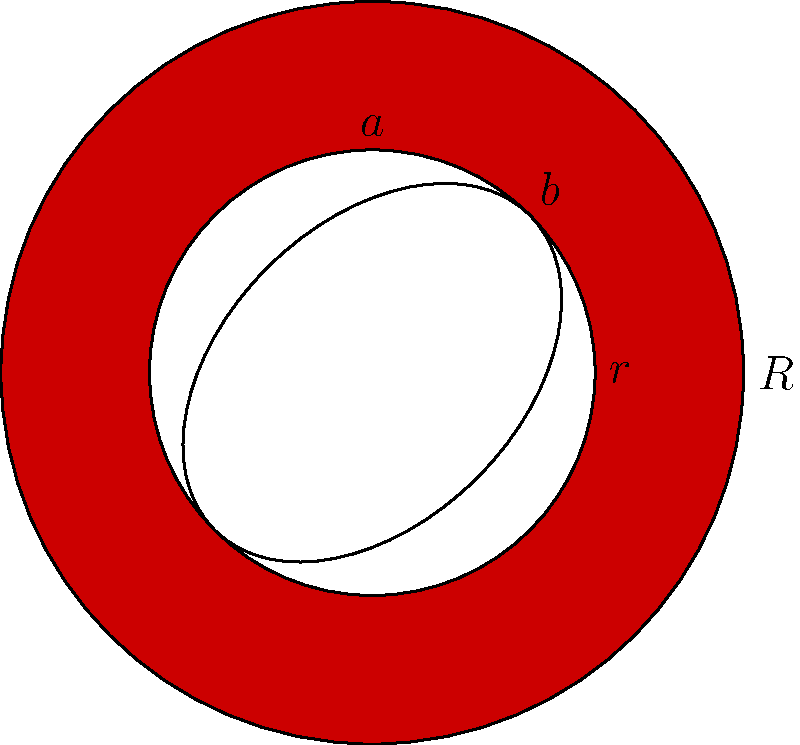A circular disk with outer radius $R$ and inner radius $r$ has an elliptical cutout as shown in the figure. The semi-major and semi-minor axes of the ellipse are $a$ and $b$ respectively. If the disk is made of a material with density $\rho$, what is the moment of inertia of this shape about an axis perpendicular to the plane of the disk and passing through its center? Let's approach this step-by-step:

1) The moment of inertia of a solid disk about its center is given by:
   $$I_{disk} = \frac{1}{2}MR^2$$
   where $M$ is the mass and $R$ is the radius.

2) For a hollow disk (annulus), we can use the parallel axis theorem:
   $$I_{annulus} = \frac{1}{2}M(R^2 + r^2)$$
   where $R$ is the outer radius and $r$ is the inner radius.

3) The mass of the annulus is:
   $$M_{annulus} = \rho\pi(R^2 - r^2)$$

4) The moment of inertia of the elliptical cutout is:
   $$I_{ellipse} = \frac{1}{4}M_{ellipse}(a^2 + b^2)$$
   where $M_{ellipse} = \rho\pi ab$

5) The total moment of inertia is the difference between the annulus and the ellipse:
   $$I_{total} = I_{annulus} - I_{ellipse}$$

6) Substituting all values:
   $$I_{total} = \frac{1}{2}\rho\pi(R^2 - r^2)(R^2 + r^2) - \frac{1}{4}\rho\pi ab(a^2 + b^2)$$

7) Simplifying:
   $$I_{total} = \frac{1}{2}\rho\pi(R^4 - r^4) - \frac{1}{4}\rho\pi ab(a^2 + b^2)$$

This is the final expression for the moment of inertia of the given shape.
Answer: $$\frac{1}{2}\rho\pi(R^4 - r^4) - \frac{1}{4}\rho\pi ab(a^2 + b^2)$$ 